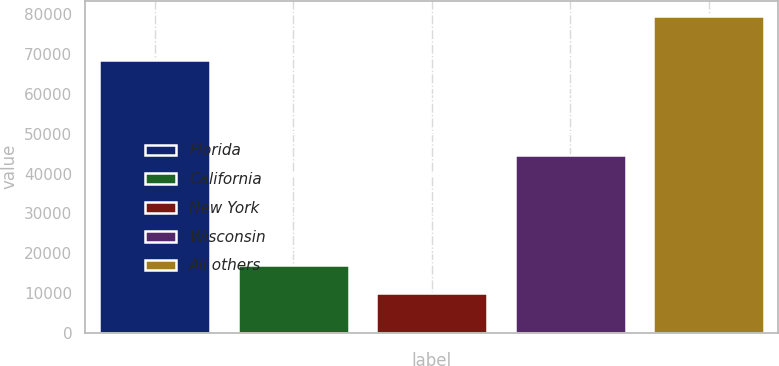Convert chart. <chart><loc_0><loc_0><loc_500><loc_500><bar_chart><fcel>Florida<fcel>California<fcel>New York<fcel>Wisconsin<fcel>All others<nl><fcel>68499<fcel>17034.1<fcel>10101<fcel>44551<fcel>79432<nl></chart> 